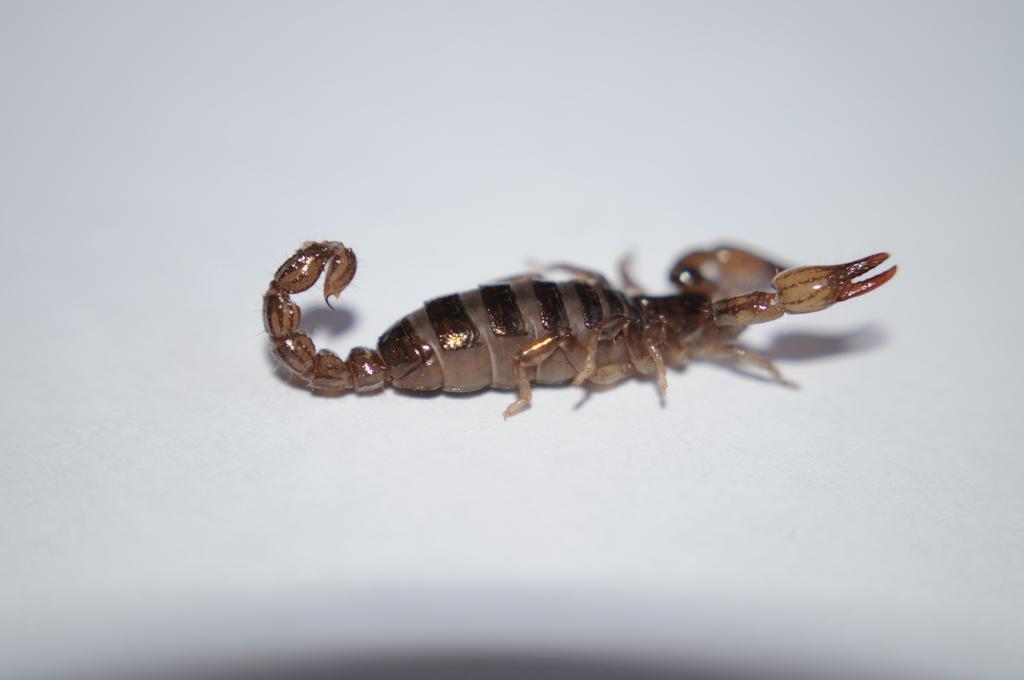Could you give a brief overview of what you see in this image? In the center of the image, we can see a scorpion on the white surface. 